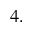Convert formula to latex. <formula><loc_0><loc_0><loc_500><loc_500>4 .</formula> 